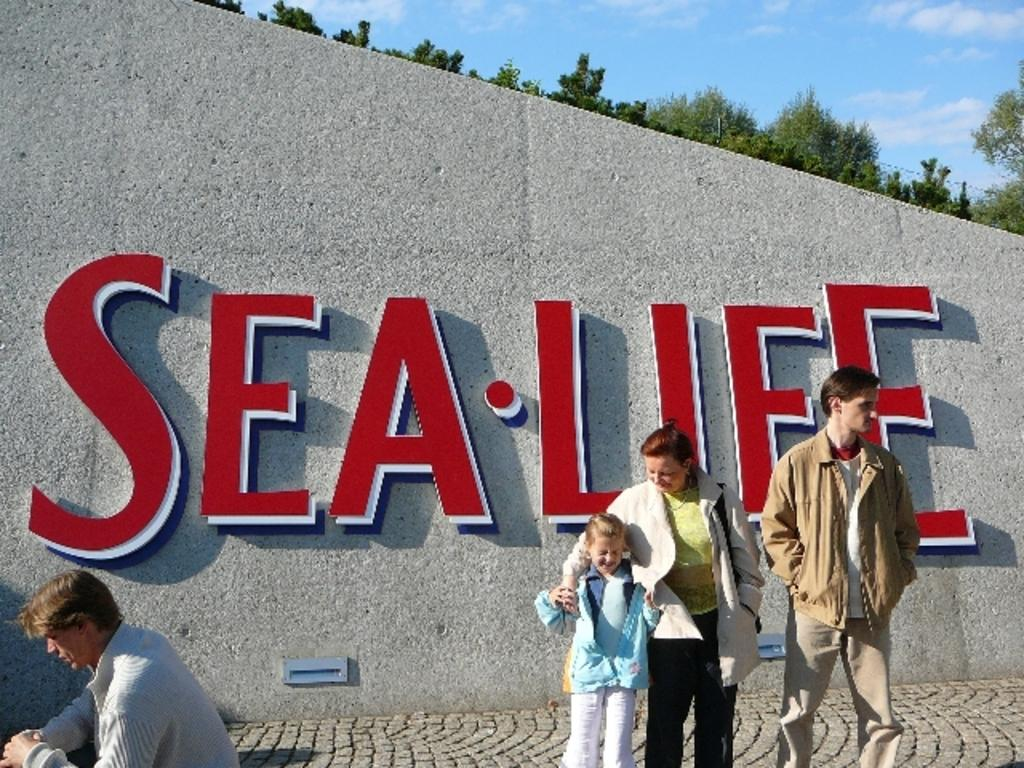How many people are in the image? There is a group of people in the image. Where are the people standing in the image? The people are standing on a platform. What can be seen on the wall in the image? There is a wall with a name on it in the image. What type of vegetation is present in the image? There are trees in the image. What is visible in the background of the image? The sky with clouds is visible in the background of the image. Can you see an aunt swimming with a jellyfish in the image? There is no aunt or jellyfish present in the image. What type of bubble is floating near the trees in the image? There is no bubble present in the image. 